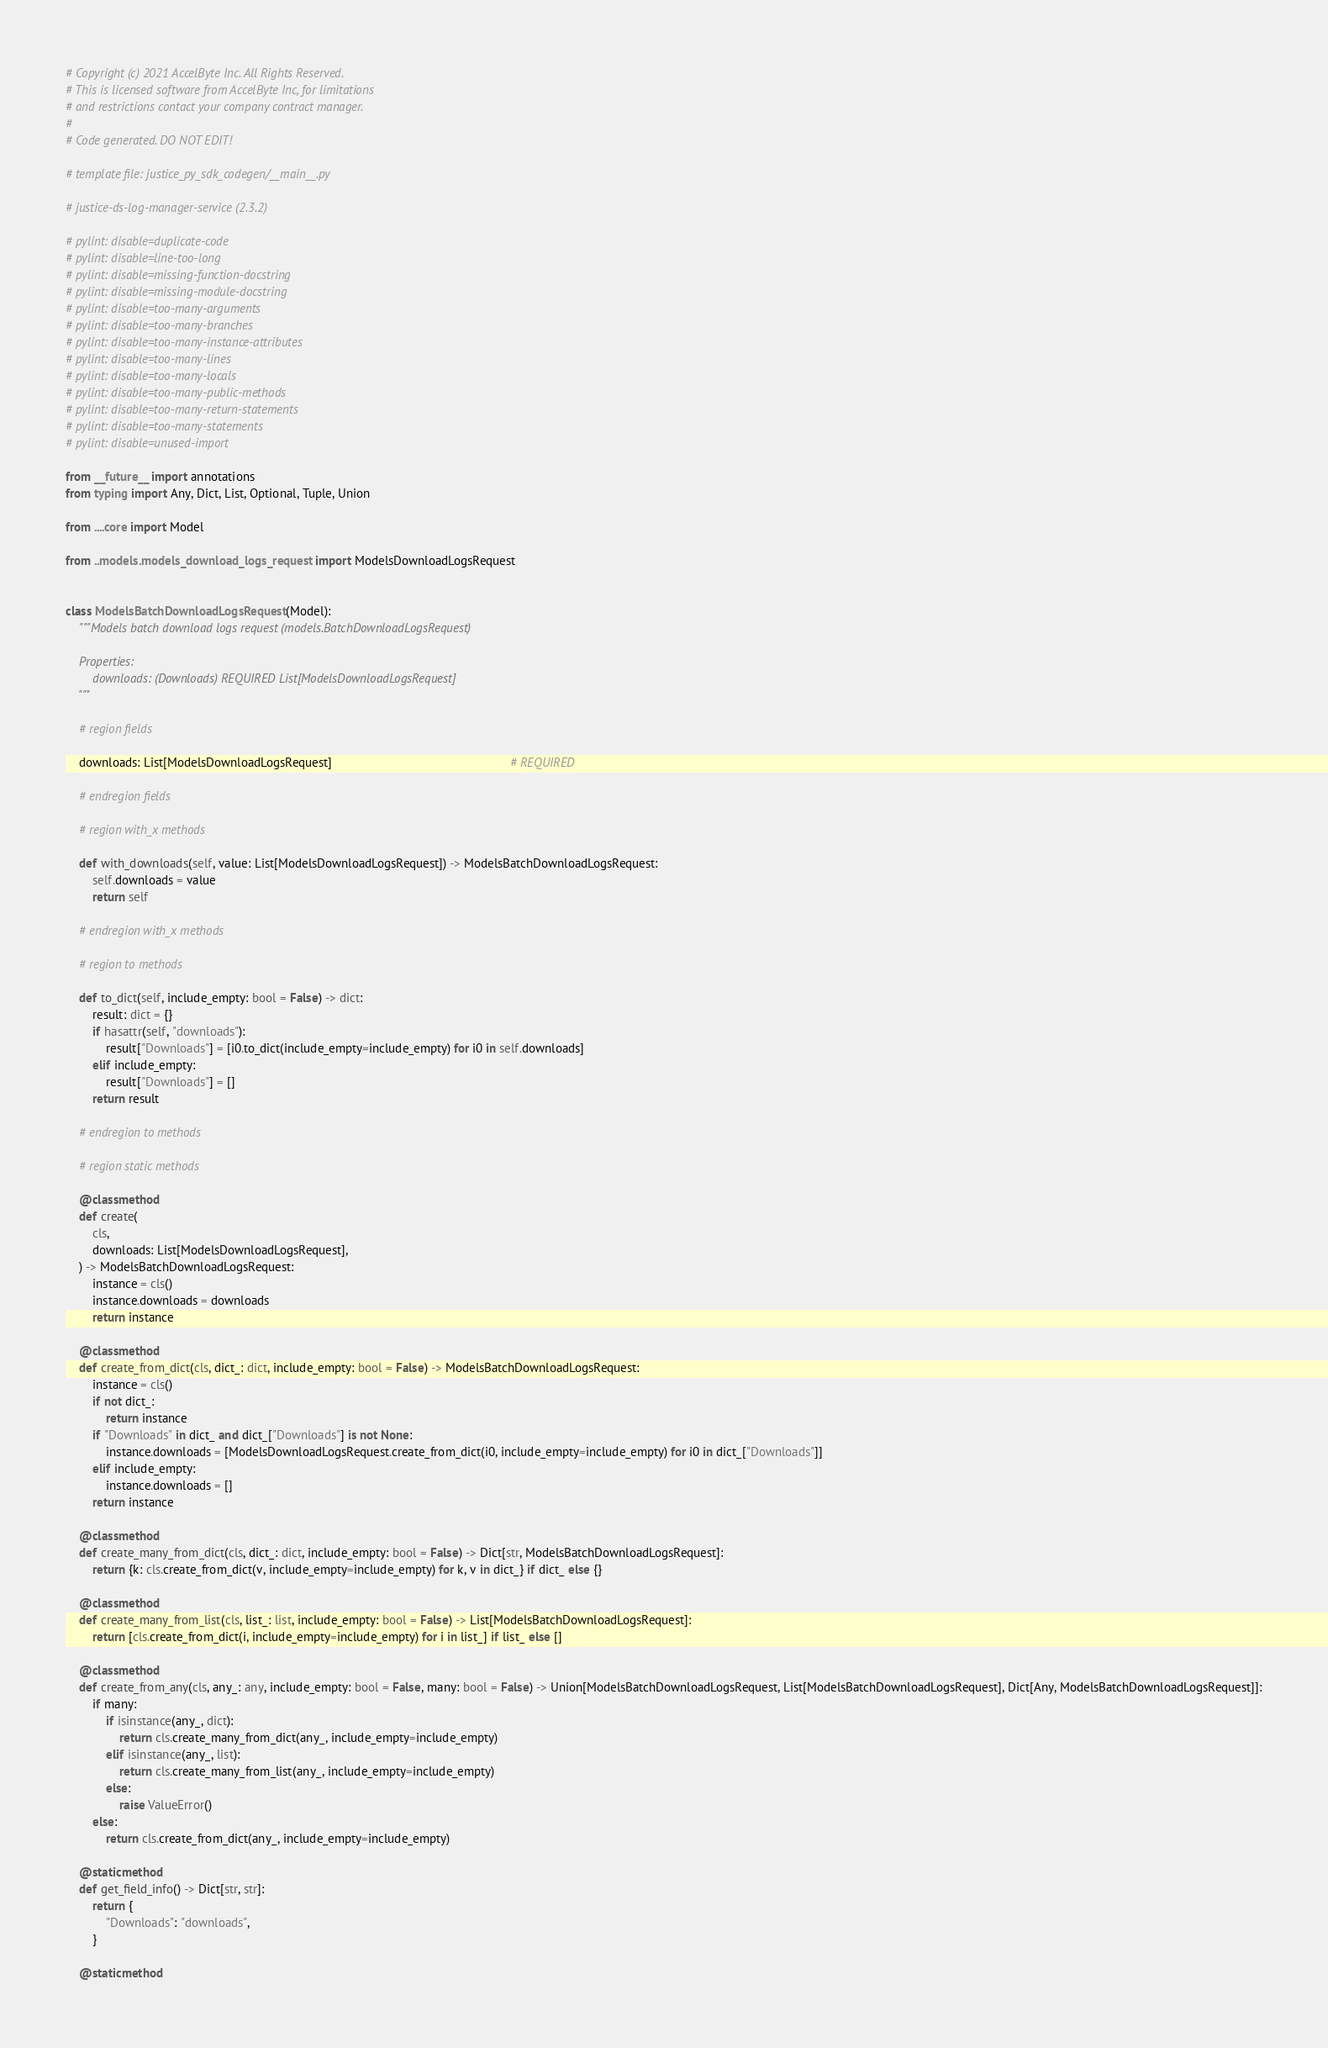Convert code to text. <code><loc_0><loc_0><loc_500><loc_500><_Python_># Copyright (c) 2021 AccelByte Inc. All Rights Reserved.
# This is licensed software from AccelByte Inc, for limitations
# and restrictions contact your company contract manager.
# 
# Code generated. DO NOT EDIT!

# template file: justice_py_sdk_codegen/__main__.py

# justice-ds-log-manager-service (2.3.2)

# pylint: disable=duplicate-code
# pylint: disable=line-too-long
# pylint: disable=missing-function-docstring
# pylint: disable=missing-module-docstring
# pylint: disable=too-many-arguments
# pylint: disable=too-many-branches
# pylint: disable=too-many-instance-attributes
# pylint: disable=too-many-lines
# pylint: disable=too-many-locals
# pylint: disable=too-many-public-methods
# pylint: disable=too-many-return-statements
# pylint: disable=too-many-statements
# pylint: disable=unused-import

from __future__ import annotations
from typing import Any, Dict, List, Optional, Tuple, Union

from ....core import Model

from ..models.models_download_logs_request import ModelsDownloadLogsRequest


class ModelsBatchDownloadLogsRequest(Model):
    """Models batch download logs request (models.BatchDownloadLogsRequest)

    Properties:
        downloads: (Downloads) REQUIRED List[ModelsDownloadLogsRequest]
    """

    # region fields

    downloads: List[ModelsDownloadLogsRequest]                                                     # REQUIRED

    # endregion fields

    # region with_x methods

    def with_downloads(self, value: List[ModelsDownloadLogsRequest]) -> ModelsBatchDownloadLogsRequest:
        self.downloads = value
        return self

    # endregion with_x methods

    # region to methods

    def to_dict(self, include_empty: bool = False) -> dict:
        result: dict = {}
        if hasattr(self, "downloads"):
            result["Downloads"] = [i0.to_dict(include_empty=include_empty) for i0 in self.downloads]
        elif include_empty:
            result["Downloads"] = []
        return result

    # endregion to methods

    # region static methods

    @classmethod
    def create(
        cls,
        downloads: List[ModelsDownloadLogsRequest],
    ) -> ModelsBatchDownloadLogsRequest:
        instance = cls()
        instance.downloads = downloads
        return instance

    @classmethod
    def create_from_dict(cls, dict_: dict, include_empty: bool = False) -> ModelsBatchDownloadLogsRequest:
        instance = cls()
        if not dict_:
            return instance
        if "Downloads" in dict_ and dict_["Downloads"] is not None:
            instance.downloads = [ModelsDownloadLogsRequest.create_from_dict(i0, include_empty=include_empty) for i0 in dict_["Downloads"]]
        elif include_empty:
            instance.downloads = []
        return instance

    @classmethod
    def create_many_from_dict(cls, dict_: dict, include_empty: bool = False) -> Dict[str, ModelsBatchDownloadLogsRequest]:
        return {k: cls.create_from_dict(v, include_empty=include_empty) for k, v in dict_} if dict_ else {}

    @classmethod
    def create_many_from_list(cls, list_: list, include_empty: bool = False) -> List[ModelsBatchDownloadLogsRequest]:
        return [cls.create_from_dict(i, include_empty=include_empty) for i in list_] if list_ else []

    @classmethod
    def create_from_any(cls, any_: any, include_empty: bool = False, many: bool = False) -> Union[ModelsBatchDownloadLogsRequest, List[ModelsBatchDownloadLogsRequest], Dict[Any, ModelsBatchDownloadLogsRequest]]:
        if many:
            if isinstance(any_, dict):
                return cls.create_many_from_dict(any_, include_empty=include_empty)
            elif isinstance(any_, list):
                return cls.create_many_from_list(any_, include_empty=include_empty)
            else:
                raise ValueError()
        else:
            return cls.create_from_dict(any_, include_empty=include_empty)

    @staticmethod
    def get_field_info() -> Dict[str, str]:
        return {
            "Downloads": "downloads",
        }

    @staticmethod</code> 